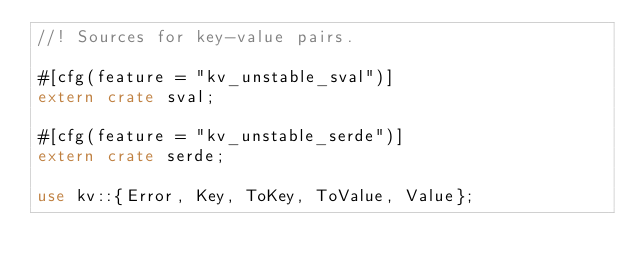Convert code to text. <code><loc_0><loc_0><loc_500><loc_500><_Rust_>//! Sources for key-value pairs.

#[cfg(feature = "kv_unstable_sval")]
extern crate sval;

#[cfg(feature = "kv_unstable_serde")]
extern crate serde;

use kv::{Error, Key, ToKey, ToValue, Value};</code> 